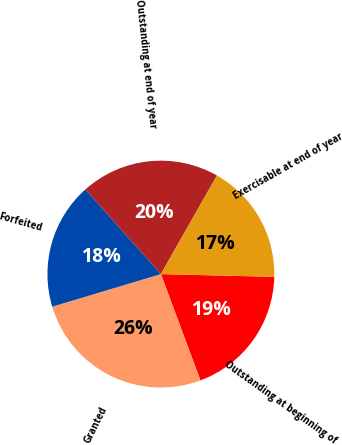Convert chart to OTSL. <chart><loc_0><loc_0><loc_500><loc_500><pie_chart><fcel>Outstanding at beginning of<fcel>Granted<fcel>Forfeited<fcel>Outstanding at end of year<fcel>Exercisable at end of year<nl><fcel>18.94%<fcel>26.03%<fcel>18.05%<fcel>19.82%<fcel>17.16%<nl></chart> 